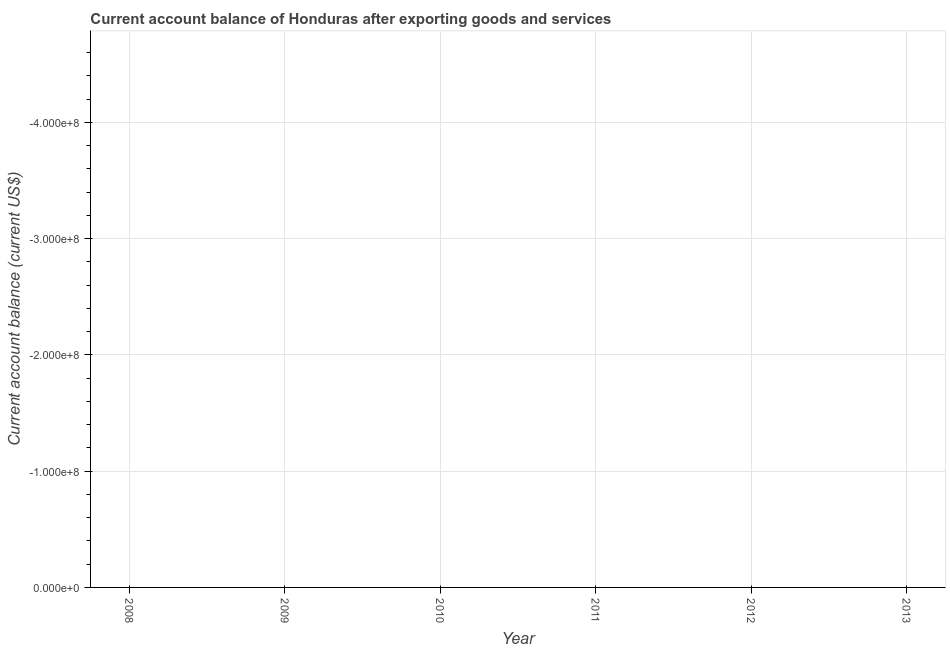What is the current account balance in 2011?
Ensure brevity in your answer.  0. Across all years, what is the minimum current account balance?
Offer a terse response. 0. What is the sum of the current account balance?
Your response must be concise. 0. In how many years, is the current account balance greater than -160000000 US$?
Offer a terse response. 0. Does the graph contain grids?
Offer a very short reply. Yes. What is the title of the graph?
Keep it short and to the point. Current account balance of Honduras after exporting goods and services. What is the label or title of the X-axis?
Your response must be concise. Year. What is the label or title of the Y-axis?
Provide a short and direct response. Current account balance (current US$). What is the Current account balance (current US$) in 2009?
Offer a terse response. 0. What is the Current account balance (current US$) of 2011?
Your answer should be very brief. 0. What is the Current account balance (current US$) in 2013?
Ensure brevity in your answer.  0. 